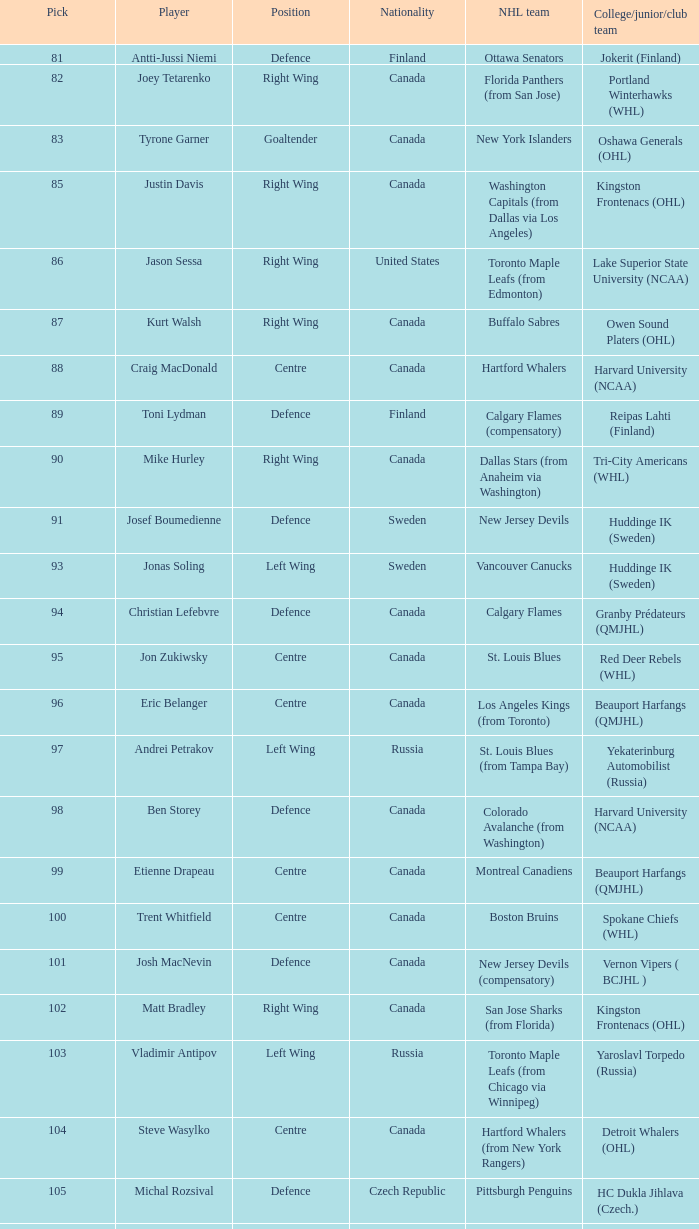What role does antti-jussi niemi perform? Defence. 